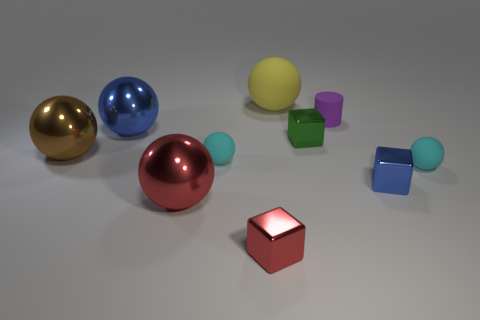Subtract all tiny blue shiny cubes. How many cubes are left? 2 Subtract all blue spheres. How many spheres are left? 5 Subtract all cubes. How many objects are left? 7 Subtract all cyan blocks. How many cyan cylinders are left? 0 Subtract 1 brown spheres. How many objects are left? 9 Subtract 4 spheres. How many spheres are left? 2 Subtract all cyan spheres. Subtract all purple cubes. How many spheres are left? 4 Subtract all large matte things. Subtract all big balls. How many objects are left? 5 Add 3 large red metal things. How many large red metal things are left? 4 Add 3 big gray spheres. How many big gray spheres exist? 3 